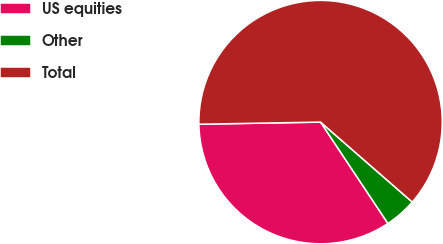Convert chart. <chart><loc_0><loc_0><loc_500><loc_500><pie_chart><fcel>US equities<fcel>Other<fcel>Total<nl><fcel>34.06%<fcel>4.25%<fcel>61.69%<nl></chart> 